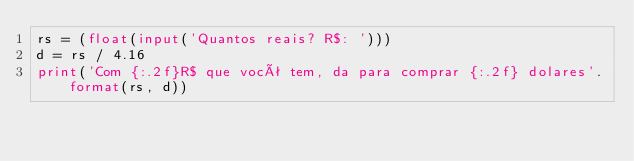Convert code to text. <code><loc_0><loc_0><loc_500><loc_500><_Python_>rs = (float(input('Quantos reais? R$: ')))
d = rs / 4.16
print('Com {:.2f}R$ que você tem, da para comprar {:.2f} dolares'.format(rs, d))</code> 